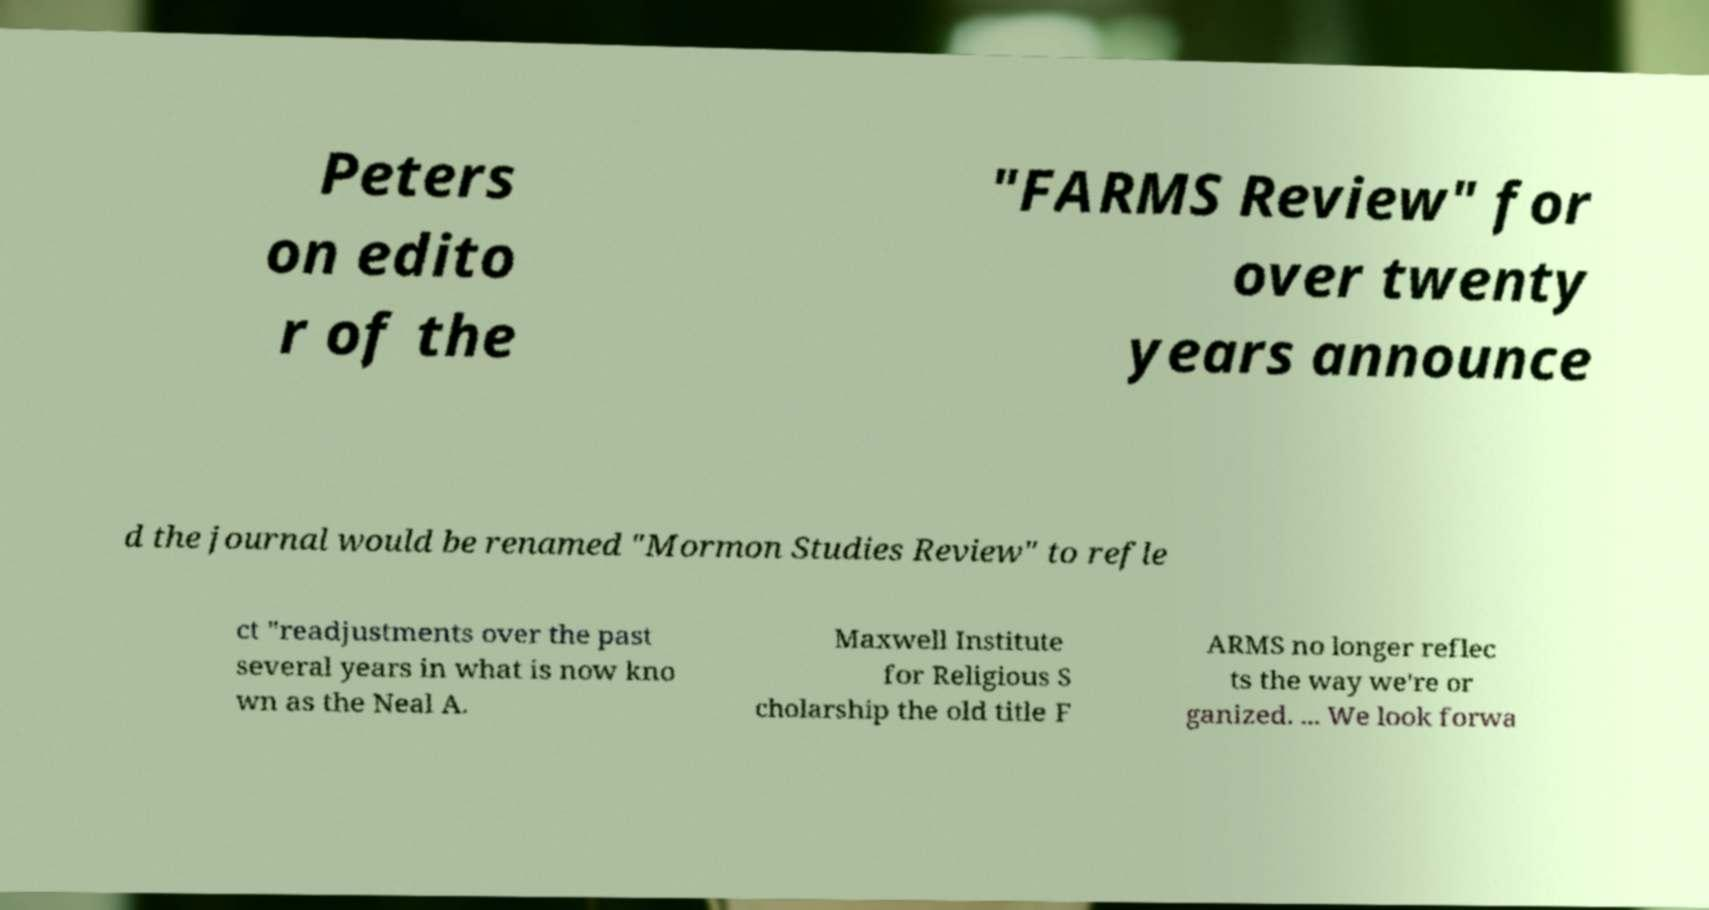Could you assist in decoding the text presented in this image and type it out clearly? Peters on edito r of the "FARMS Review" for over twenty years announce d the journal would be renamed "Mormon Studies Review" to refle ct "readjustments over the past several years in what is now kno wn as the Neal A. Maxwell Institute for Religious S cholarship the old title F ARMS no longer reflec ts the way we're or ganized. ... We look forwa 